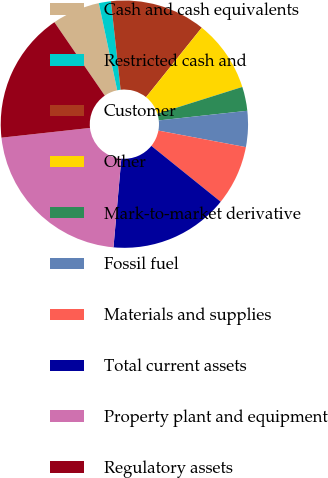Convert chart to OTSL. <chart><loc_0><loc_0><loc_500><loc_500><pie_chart><fcel>Cash and cash equivalents<fcel>Restricted cash and<fcel>Customer<fcel>Other<fcel>Mark-to-market derivative<fcel>Fossil fuel<fcel>Materials and supplies<fcel>Total current assets<fcel>Property plant and equipment<fcel>Regulatory assets<nl><fcel>6.26%<fcel>1.58%<fcel>12.49%<fcel>9.38%<fcel>3.14%<fcel>4.7%<fcel>7.82%<fcel>15.61%<fcel>21.85%<fcel>17.17%<nl></chart> 